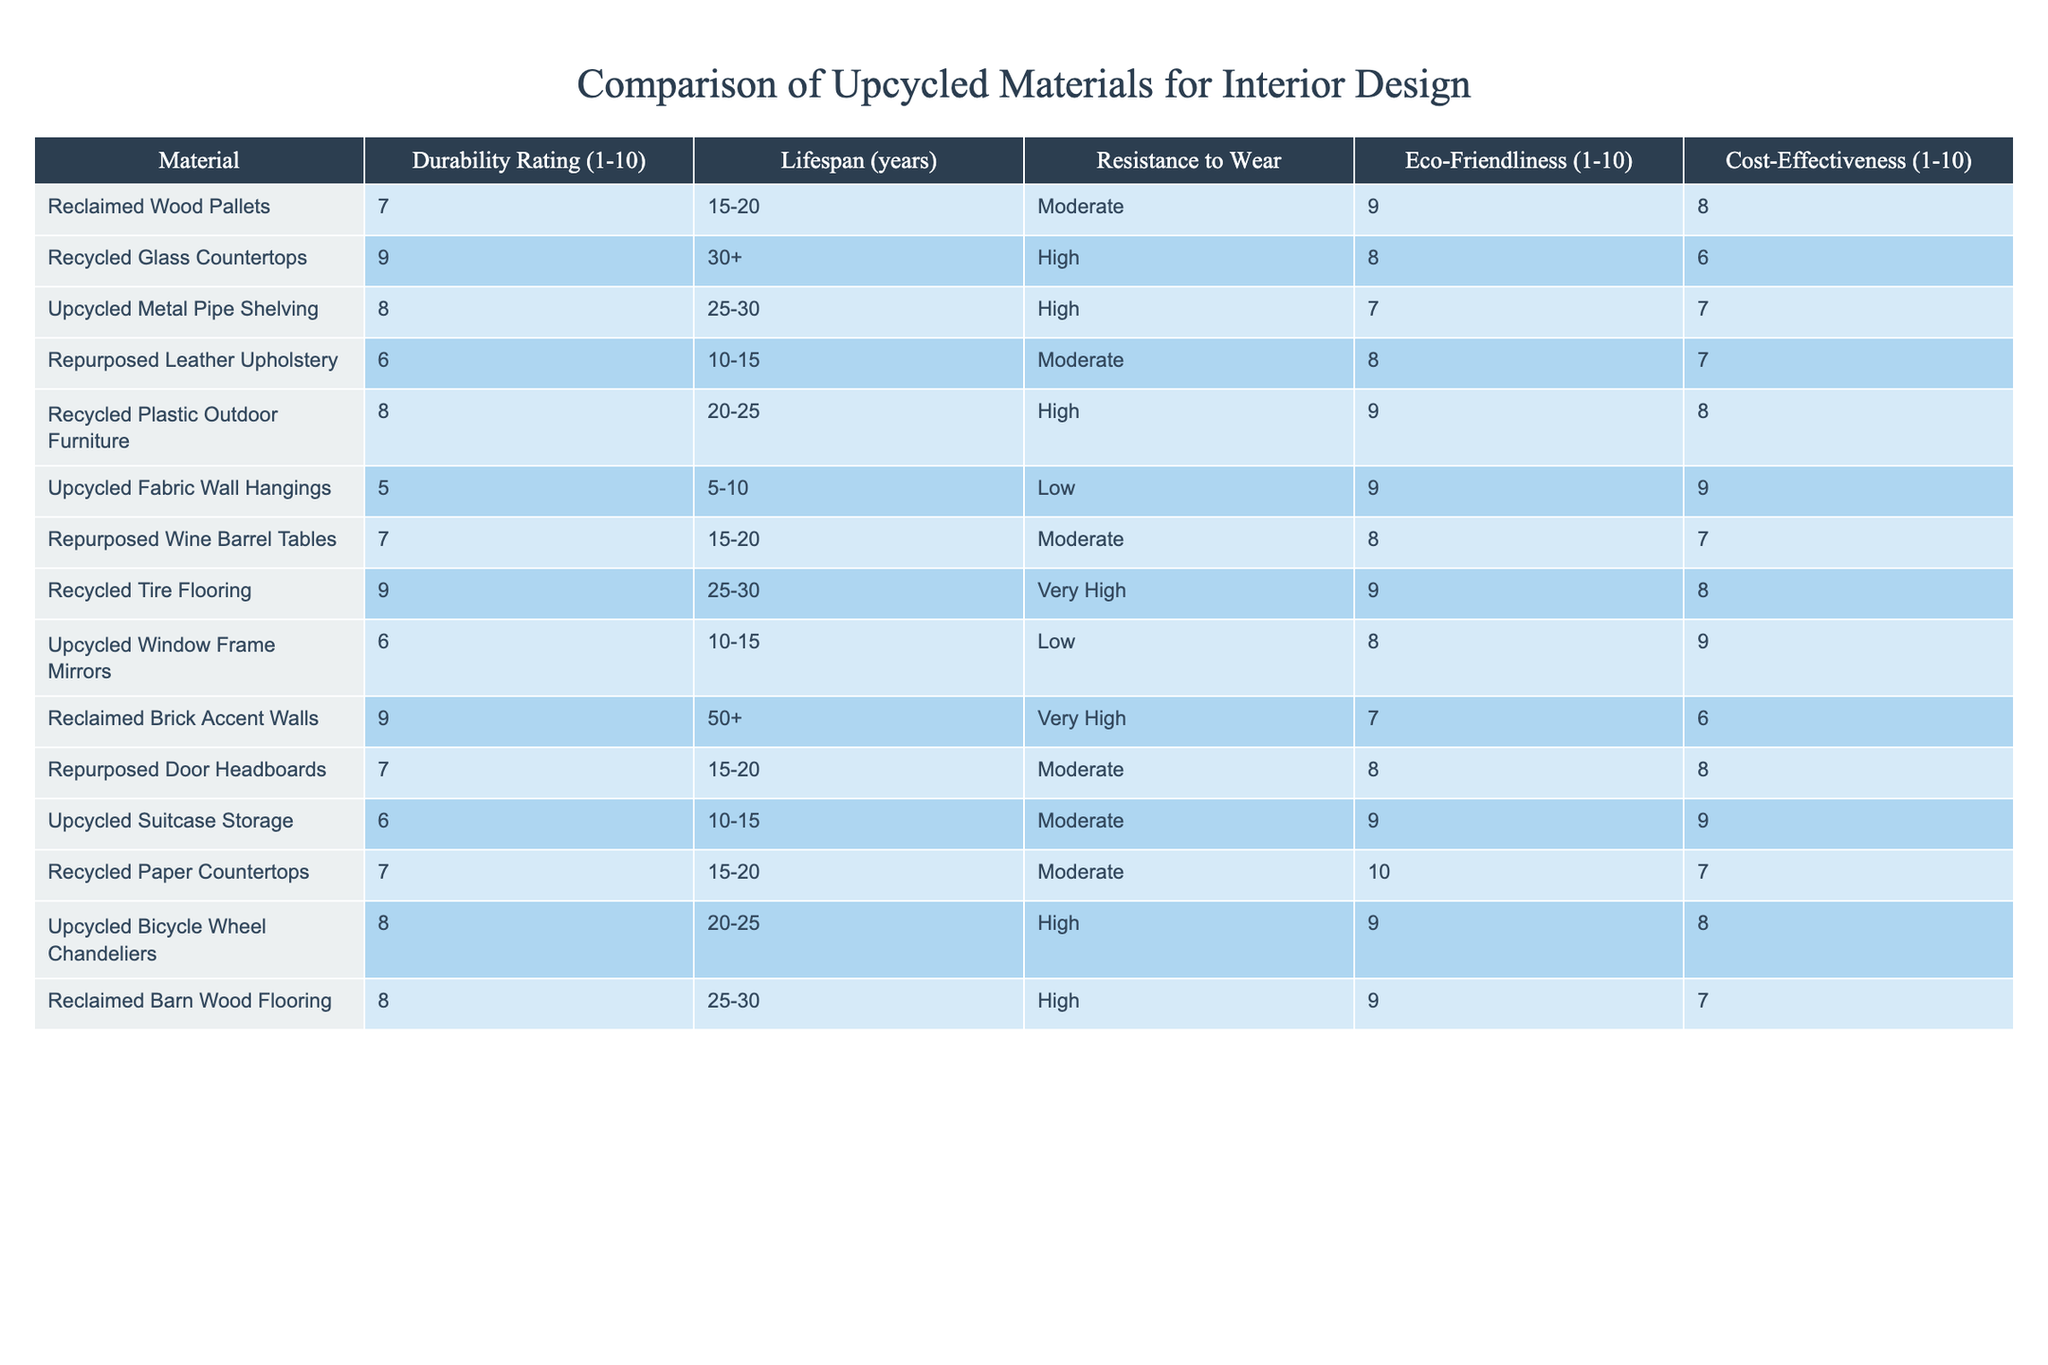What is the durability rating of recycled glass countertops? The durability rating for recycled glass countertops is listed directly in the table under the "Durability Rating (1-10)" column.
Answer: 9 Which material has the highest lifespan and what is its rating? According to the table, reclaimed brick accent walls have a lifespan of 50+ years, which is the highest listed in the "Lifespan (years)" column.
Answer: Reclaimed brick accent walls; 9 Is upcycled fabric wall hangings eco-friendly? The eco-friendliness rating of upcycled fabric wall hangings is 9, as indicated in the corresponding column.
Answer: Yes What is the average durability rating of materials with a lifespan of 10-15 years? First, identify the materials with this lifespan: repurposed leather upholstery, upcycled window frame mirrors, upcycled suitcase storage, and recycled paper countertops. Their durability ratings are 6, 6, 6, and 7, respectively. The average is calculated by adding these ratings (6 + 6 + 6 + 7 = 25) and dividing by the number of materials (25/4 = 6.25).
Answer: 6.25 Which two materials have the same durability rating and a lifespan of 15-20 years? Referring to the table, both reclaimed wood pallets and repurposed wine barrel tables have a durability rating of 7 and a lifespan of 15-20 years.
Answer: Reclaimed wood pallets and repurposed wine barrel tables How many materials have a durability rating of 8? By examining the table, the materials with a durability rating of 8 are the recycled plastic outdoor furniture, upcycled metal pipe shelving, upcycled bicycle wheel chandeliers, and reclaimed barn wood flooring. This makes a total of 4 materials.
Answer: 4 Are there any materials with a low resistance to wear? The table indicates that both upcycled fabric wall hangings and upcycled window frame mirrors have a low resistance to wear, signifying they are less durable in this aspect.
Answer: Yes What is the total cost-effectiveness score for materials rated at 9 for eco-friendliness? The materials rated at 9 for eco-friendliness are reclaimed wood pallets, recycled plastic outdoor furniture, and upcycled fabric wall hangings. Their cost-effectiveness scores are 8, 8, and 9, respectively. Adding these scores together gives 8 + 8 + 9 = 25.
Answer: 25 